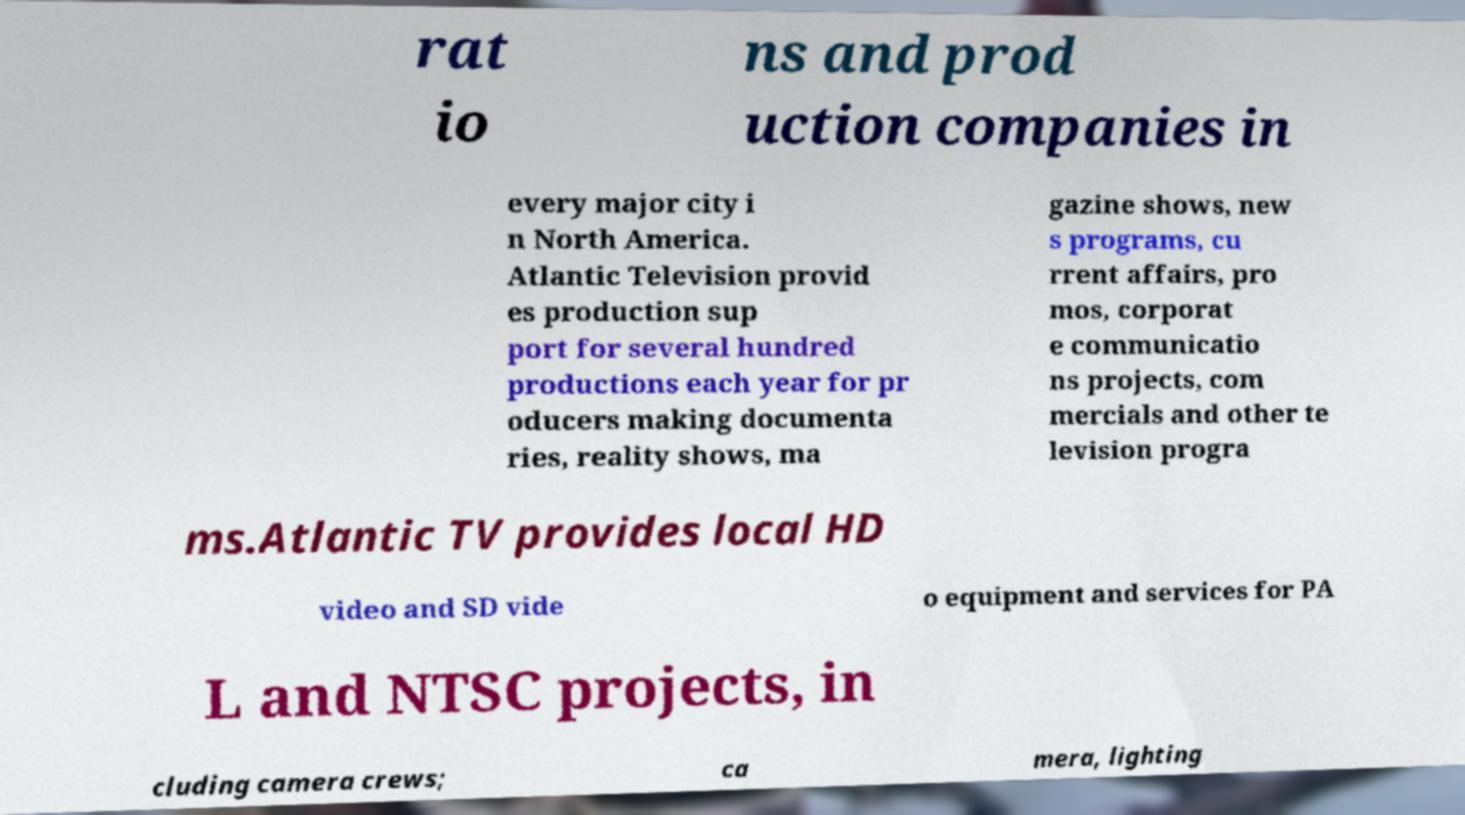Could you assist in decoding the text presented in this image and type it out clearly? rat io ns and prod uction companies in every major city i n North America. Atlantic Television provid es production sup port for several hundred productions each year for pr oducers making documenta ries, reality shows, ma gazine shows, new s programs, cu rrent affairs, pro mos, corporat e communicatio ns projects, com mercials and other te levision progra ms.Atlantic TV provides local HD video and SD vide o equipment and services for PA L and NTSC projects, in cluding camera crews; ca mera, lighting 